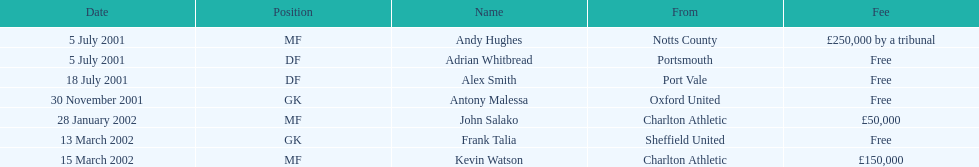Whos name is listed last on the chart? Kevin Watson. 